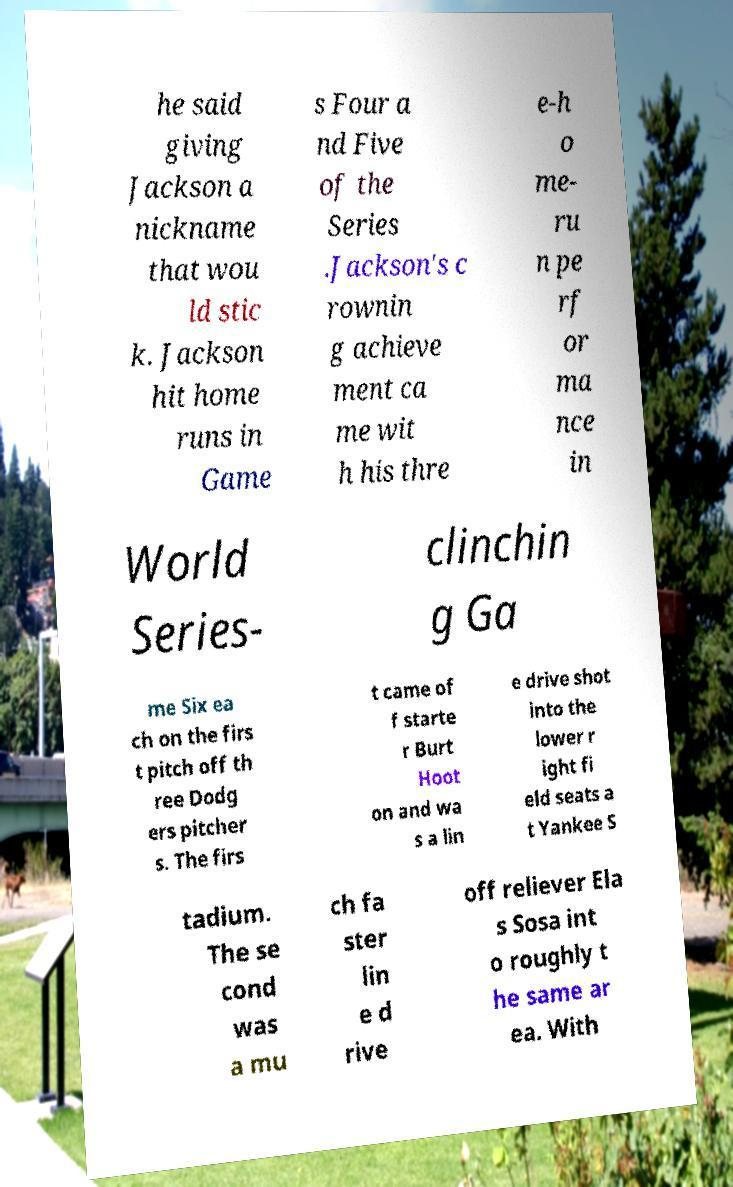Please identify and transcribe the text found in this image. he said giving Jackson a nickname that wou ld stic k. Jackson hit home runs in Game s Four a nd Five of the Series .Jackson's c rownin g achieve ment ca me wit h his thre e-h o me- ru n pe rf or ma nce in World Series- clinchin g Ga me Six ea ch on the firs t pitch off th ree Dodg ers pitcher s. The firs t came of f starte r Burt Hoot on and wa s a lin e drive shot into the lower r ight fi eld seats a t Yankee S tadium. The se cond was a mu ch fa ster lin e d rive off reliever Ela s Sosa int o roughly t he same ar ea. With 